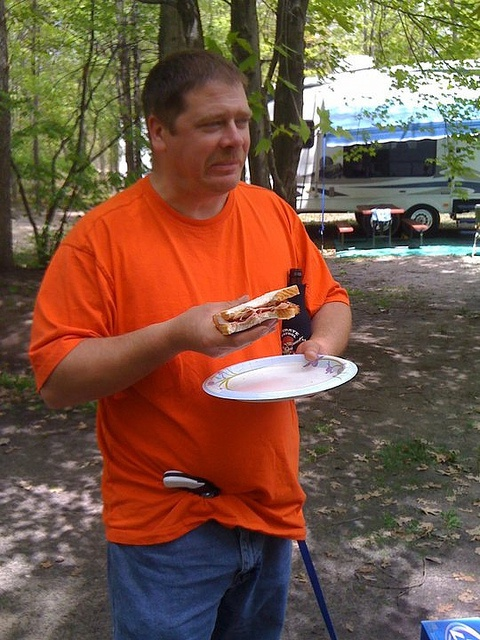Describe the objects in this image and their specific colors. I can see people in darkgreen, maroon, red, and black tones, bus in darkgreen, white, gray, black, and darkgray tones, sandwich in black, brown, lightgray, and tan tones, bottle in black, maroon, and brown tones, and dining table in darkgreen, black, white, gray, and maroon tones in this image. 